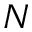<formula> <loc_0><loc_0><loc_500><loc_500>N</formula> 